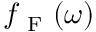<formula> <loc_0><loc_0><loc_500><loc_500>f _ { F } ( \omega )</formula> 